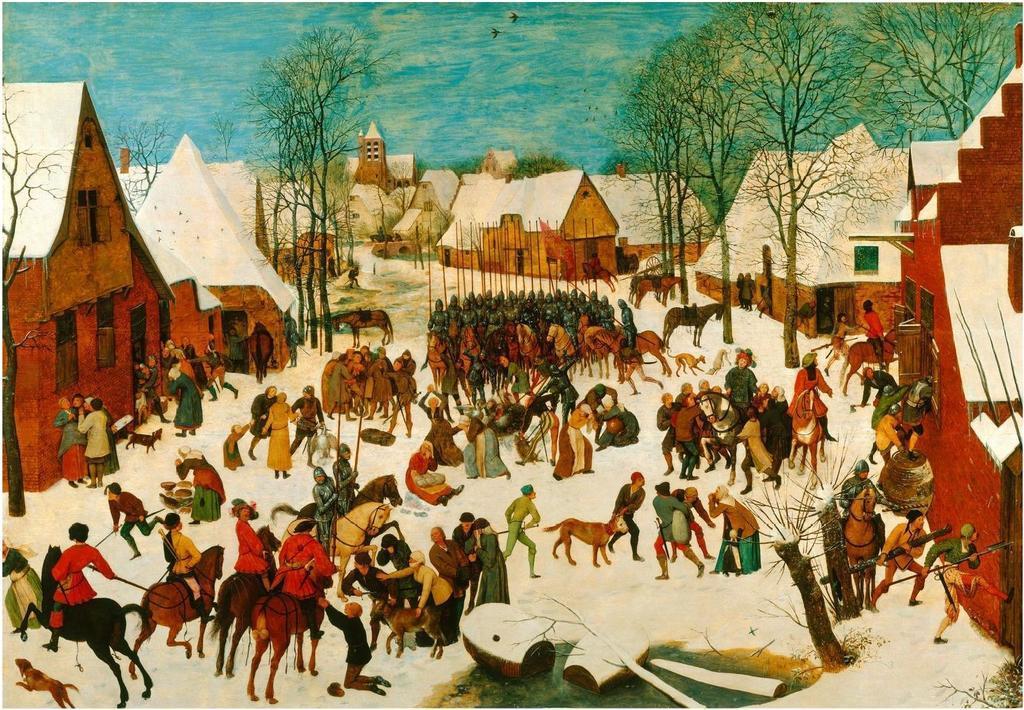Please provide a concise description of this image. This image consists of a poster with an art on it. At the top of the image there is the sky with clouds. In the middle of the image there are many people standing on the ground and a few are walking. Many people are riding on the horses and there are a few animals on the ground. On the left and right sides of the image there are a few houses with walls, windows, roofs and doors. There are a few trees. 